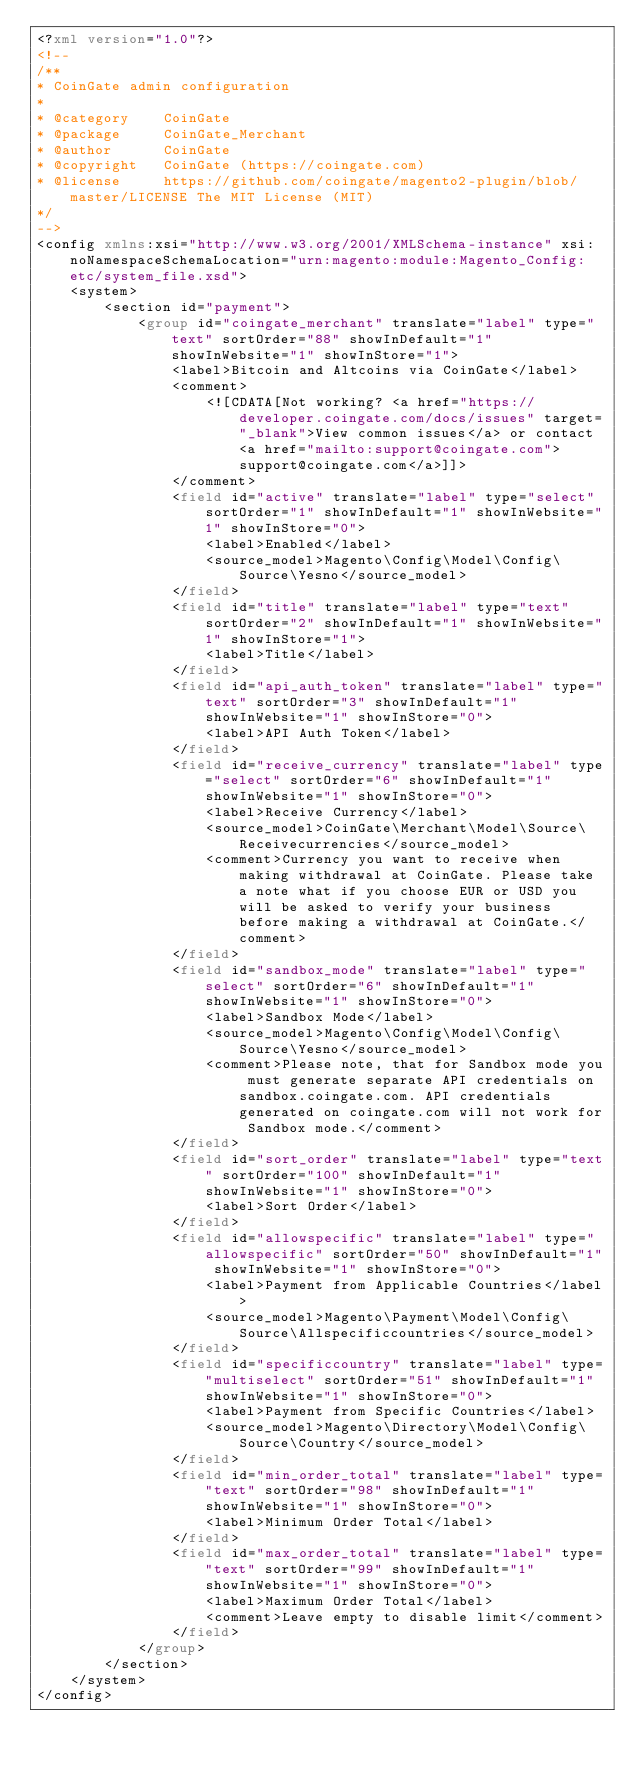<code> <loc_0><loc_0><loc_500><loc_500><_XML_><?xml version="1.0"?>
<!--
/**
* CoinGate admin configuration
*
* @category    CoinGate
* @package     CoinGate_Merchant
* @author      CoinGate
* @copyright   CoinGate (https://coingate.com)
* @license     https://github.com/coingate/magento2-plugin/blob/master/LICENSE The MIT License (MIT)
*/
-->
<config xmlns:xsi="http://www.w3.org/2001/XMLSchema-instance" xsi:noNamespaceSchemaLocation="urn:magento:module:Magento_Config:etc/system_file.xsd">
    <system>
        <section id="payment">
            <group id="coingate_merchant" translate="label" type="text" sortOrder="88" showInDefault="1" showInWebsite="1" showInStore="1">
                <label>Bitcoin and Altcoins via CoinGate</label>
                <comment>
                    <![CDATA[Not working? <a href="https://developer.coingate.com/docs/issues" target="_blank">View common issues</a> or contact <a href="mailto:support@coingate.com">support@coingate.com</a>]]>
                </comment>
                <field id="active" translate="label" type="select" sortOrder="1" showInDefault="1" showInWebsite="1" showInStore="0">
                    <label>Enabled</label>
                    <source_model>Magento\Config\Model\Config\Source\Yesno</source_model>
                </field>
                <field id="title" translate="label" type="text" sortOrder="2" showInDefault="1" showInWebsite="1" showInStore="1">
                    <label>Title</label>
                </field>
                <field id="api_auth_token" translate="label" type="text" sortOrder="3" showInDefault="1" showInWebsite="1" showInStore="0">
                    <label>API Auth Token</label>
                </field>
                <field id="receive_currency" translate="label" type="select" sortOrder="6" showInDefault="1" showInWebsite="1" showInStore="0">
                    <label>Receive Currency</label>
                    <source_model>CoinGate\Merchant\Model\Source\Receivecurrencies</source_model>
                    <comment>Currency you want to receive when making withdrawal at CoinGate. Please take a note what if you choose EUR or USD you will be asked to verify your business before making a withdrawal at CoinGate.</comment>
                </field>
                <field id="sandbox_mode" translate="label" type="select" sortOrder="6" showInDefault="1" showInWebsite="1" showInStore="0">
                    <label>Sandbox Mode</label>
                    <source_model>Magento\Config\Model\Config\Source\Yesno</source_model>
                    <comment>Please note, that for Sandbox mode you must generate separate API credentials on sandbox.coingate.com. API credentials generated on coingate.com will not work for Sandbox mode.</comment>
                </field>
                <field id="sort_order" translate="label" type="text" sortOrder="100" showInDefault="1" showInWebsite="1" showInStore="0">
                    <label>Sort Order</label>
                </field>
                <field id="allowspecific" translate="label" type="allowspecific" sortOrder="50" showInDefault="1" showInWebsite="1" showInStore="0">
                    <label>Payment from Applicable Countries</label>
                    <source_model>Magento\Payment\Model\Config\Source\Allspecificcountries</source_model>
                </field>
                <field id="specificcountry" translate="label" type="multiselect" sortOrder="51" showInDefault="1" showInWebsite="1" showInStore="0">
                    <label>Payment from Specific Countries</label>
                    <source_model>Magento\Directory\Model\Config\Source\Country</source_model>
                </field>
                <field id="min_order_total" translate="label" type="text" sortOrder="98" showInDefault="1" showInWebsite="1" showInStore="0">
                    <label>Minimum Order Total</label>
                </field>
                <field id="max_order_total" translate="label" type="text" sortOrder="99" showInDefault="1" showInWebsite="1" showInStore="0">
                    <label>Maximum Order Total</label>
                    <comment>Leave empty to disable limit</comment>
                </field>
            </group>
        </section>
    </system>
</config>
</code> 